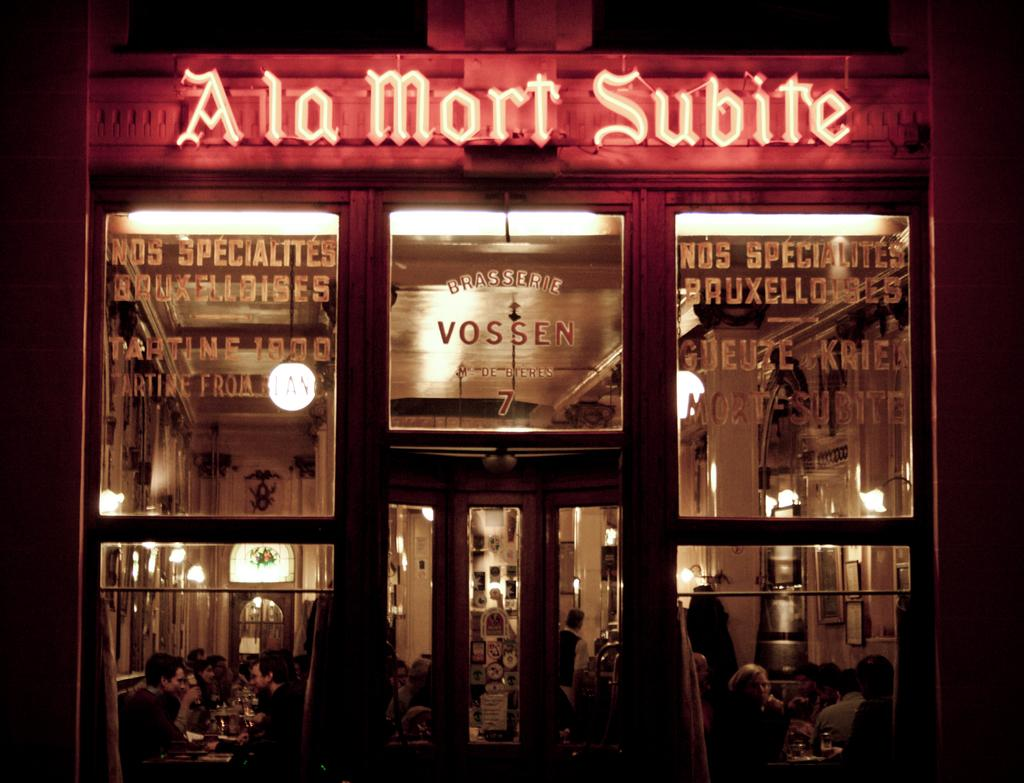What is happening inside the building in the image? There are people inside the building. What can be seen in the middle of the image? There are lights in the middle of the image. What type of wine is being served to the people inside the building? There is no wine present in the image; it only shows people inside the building and lights in the middle. 